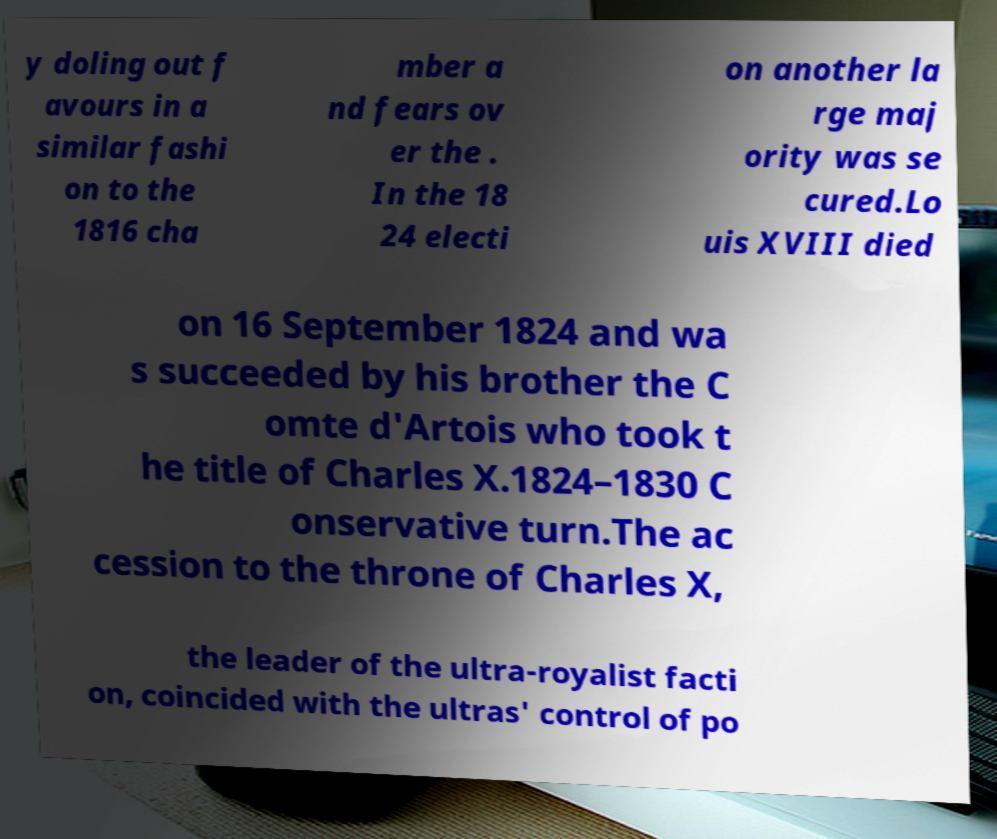Can you accurately transcribe the text from the provided image for me? y doling out f avours in a similar fashi on to the 1816 cha mber a nd fears ov er the . In the 18 24 electi on another la rge maj ority was se cured.Lo uis XVIII died on 16 September 1824 and wa s succeeded by his brother the C omte d'Artois who took t he title of Charles X.1824–1830 C onservative turn.The ac cession to the throne of Charles X, the leader of the ultra-royalist facti on, coincided with the ultras' control of po 